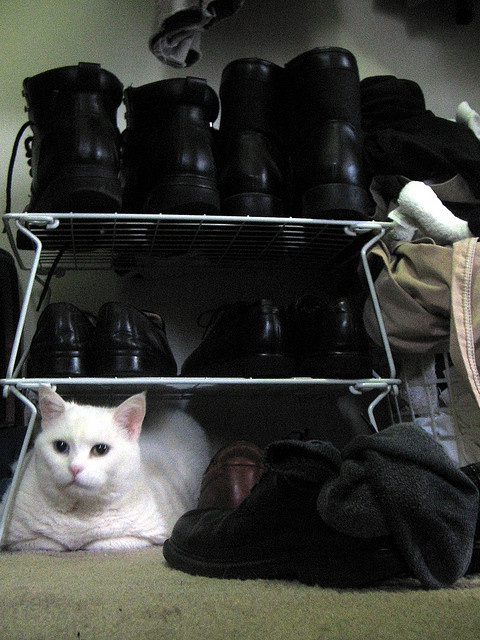Describe the objects in this image and their specific colors. I can see a cat in gray, darkgray, lightgray, and black tones in this image. 